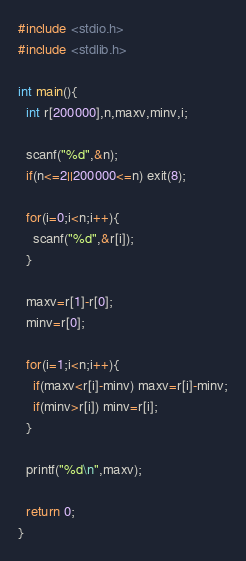<code> <loc_0><loc_0><loc_500><loc_500><_C_>#include <stdio.h>
#include <stdlib.h>

int main(){
  int r[200000],n,maxv,minv,i;

  scanf("%d",&n);
  if(n<=2||200000<=n) exit(8); 

  for(i=0;i<n;i++){
    scanf("%d",&r[i]);
  }
  
  maxv=r[1]-r[0];
  minv=r[0];
  
  for(i=1;i<n;i++){
    if(maxv<r[i]-minv) maxv=r[i]-minv;
    if(minv>r[i]) minv=r[i];
  }

  printf("%d\n",maxv);

  return 0;
}</code> 